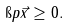<formula> <loc_0><loc_0><loc_500><loc_500>\i p { \vec { x } } \geq 0 .</formula> 